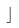<formula> <loc_0><loc_0><loc_500><loc_500>\rfloor</formula> 